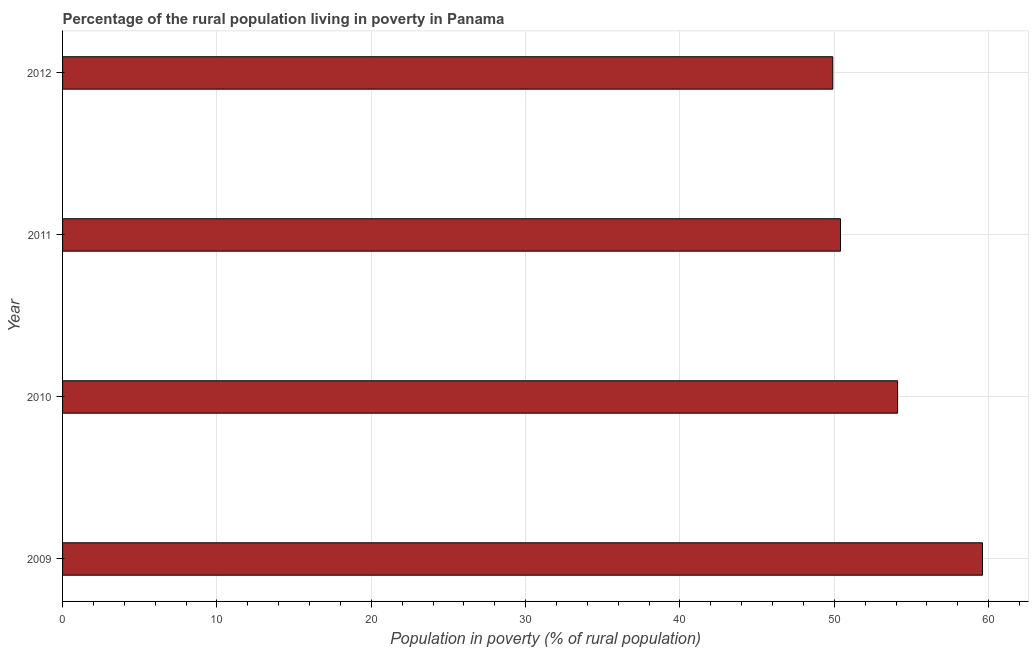What is the title of the graph?
Offer a very short reply. Percentage of the rural population living in poverty in Panama. What is the label or title of the X-axis?
Provide a succinct answer. Population in poverty (% of rural population). What is the label or title of the Y-axis?
Provide a succinct answer. Year. What is the percentage of rural population living below poverty line in 2011?
Ensure brevity in your answer.  50.4. Across all years, what is the maximum percentage of rural population living below poverty line?
Your response must be concise. 59.6. Across all years, what is the minimum percentage of rural population living below poverty line?
Offer a terse response. 49.9. In which year was the percentage of rural population living below poverty line maximum?
Offer a very short reply. 2009. What is the sum of the percentage of rural population living below poverty line?
Your answer should be very brief. 214. What is the difference between the percentage of rural population living below poverty line in 2011 and 2012?
Your response must be concise. 0.5. What is the average percentage of rural population living below poverty line per year?
Give a very brief answer. 53.5. What is the median percentage of rural population living below poverty line?
Offer a terse response. 52.25. Do a majority of the years between 2009 and 2010 (inclusive) have percentage of rural population living below poverty line greater than 46 %?
Provide a succinct answer. Yes. What is the ratio of the percentage of rural population living below poverty line in 2009 to that in 2012?
Keep it short and to the point. 1.19. Is the percentage of rural population living below poverty line in 2009 less than that in 2012?
Your answer should be very brief. No. What is the difference between the highest and the second highest percentage of rural population living below poverty line?
Provide a succinct answer. 5.5. Is the sum of the percentage of rural population living below poverty line in 2009 and 2010 greater than the maximum percentage of rural population living below poverty line across all years?
Offer a very short reply. Yes. What is the difference between the highest and the lowest percentage of rural population living below poverty line?
Your answer should be very brief. 9.7. How many bars are there?
Keep it short and to the point. 4. Are all the bars in the graph horizontal?
Provide a succinct answer. Yes. What is the Population in poverty (% of rural population) of 2009?
Keep it short and to the point. 59.6. What is the Population in poverty (% of rural population) in 2010?
Provide a short and direct response. 54.1. What is the Population in poverty (% of rural population) in 2011?
Make the answer very short. 50.4. What is the Population in poverty (% of rural population) in 2012?
Provide a short and direct response. 49.9. What is the difference between the Population in poverty (% of rural population) in 2009 and 2011?
Provide a short and direct response. 9.2. What is the difference between the Population in poverty (% of rural population) in 2009 and 2012?
Provide a short and direct response. 9.7. What is the difference between the Population in poverty (% of rural population) in 2010 and 2012?
Give a very brief answer. 4.2. What is the ratio of the Population in poverty (% of rural population) in 2009 to that in 2010?
Your answer should be compact. 1.1. What is the ratio of the Population in poverty (% of rural population) in 2009 to that in 2011?
Your answer should be very brief. 1.18. What is the ratio of the Population in poverty (% of rural population) in 2009 to that in 2012?
Make the answer very short. 1.19. What is the ratio of the Population in poverty (% of rural population) in 2010 to that in 2011?
Provide a short and direct response. 1.07. What is the ratio of the Population in poverty (% of rural population) in 2010 to that in 2012?
Provide a short and direct response. 1.08. 